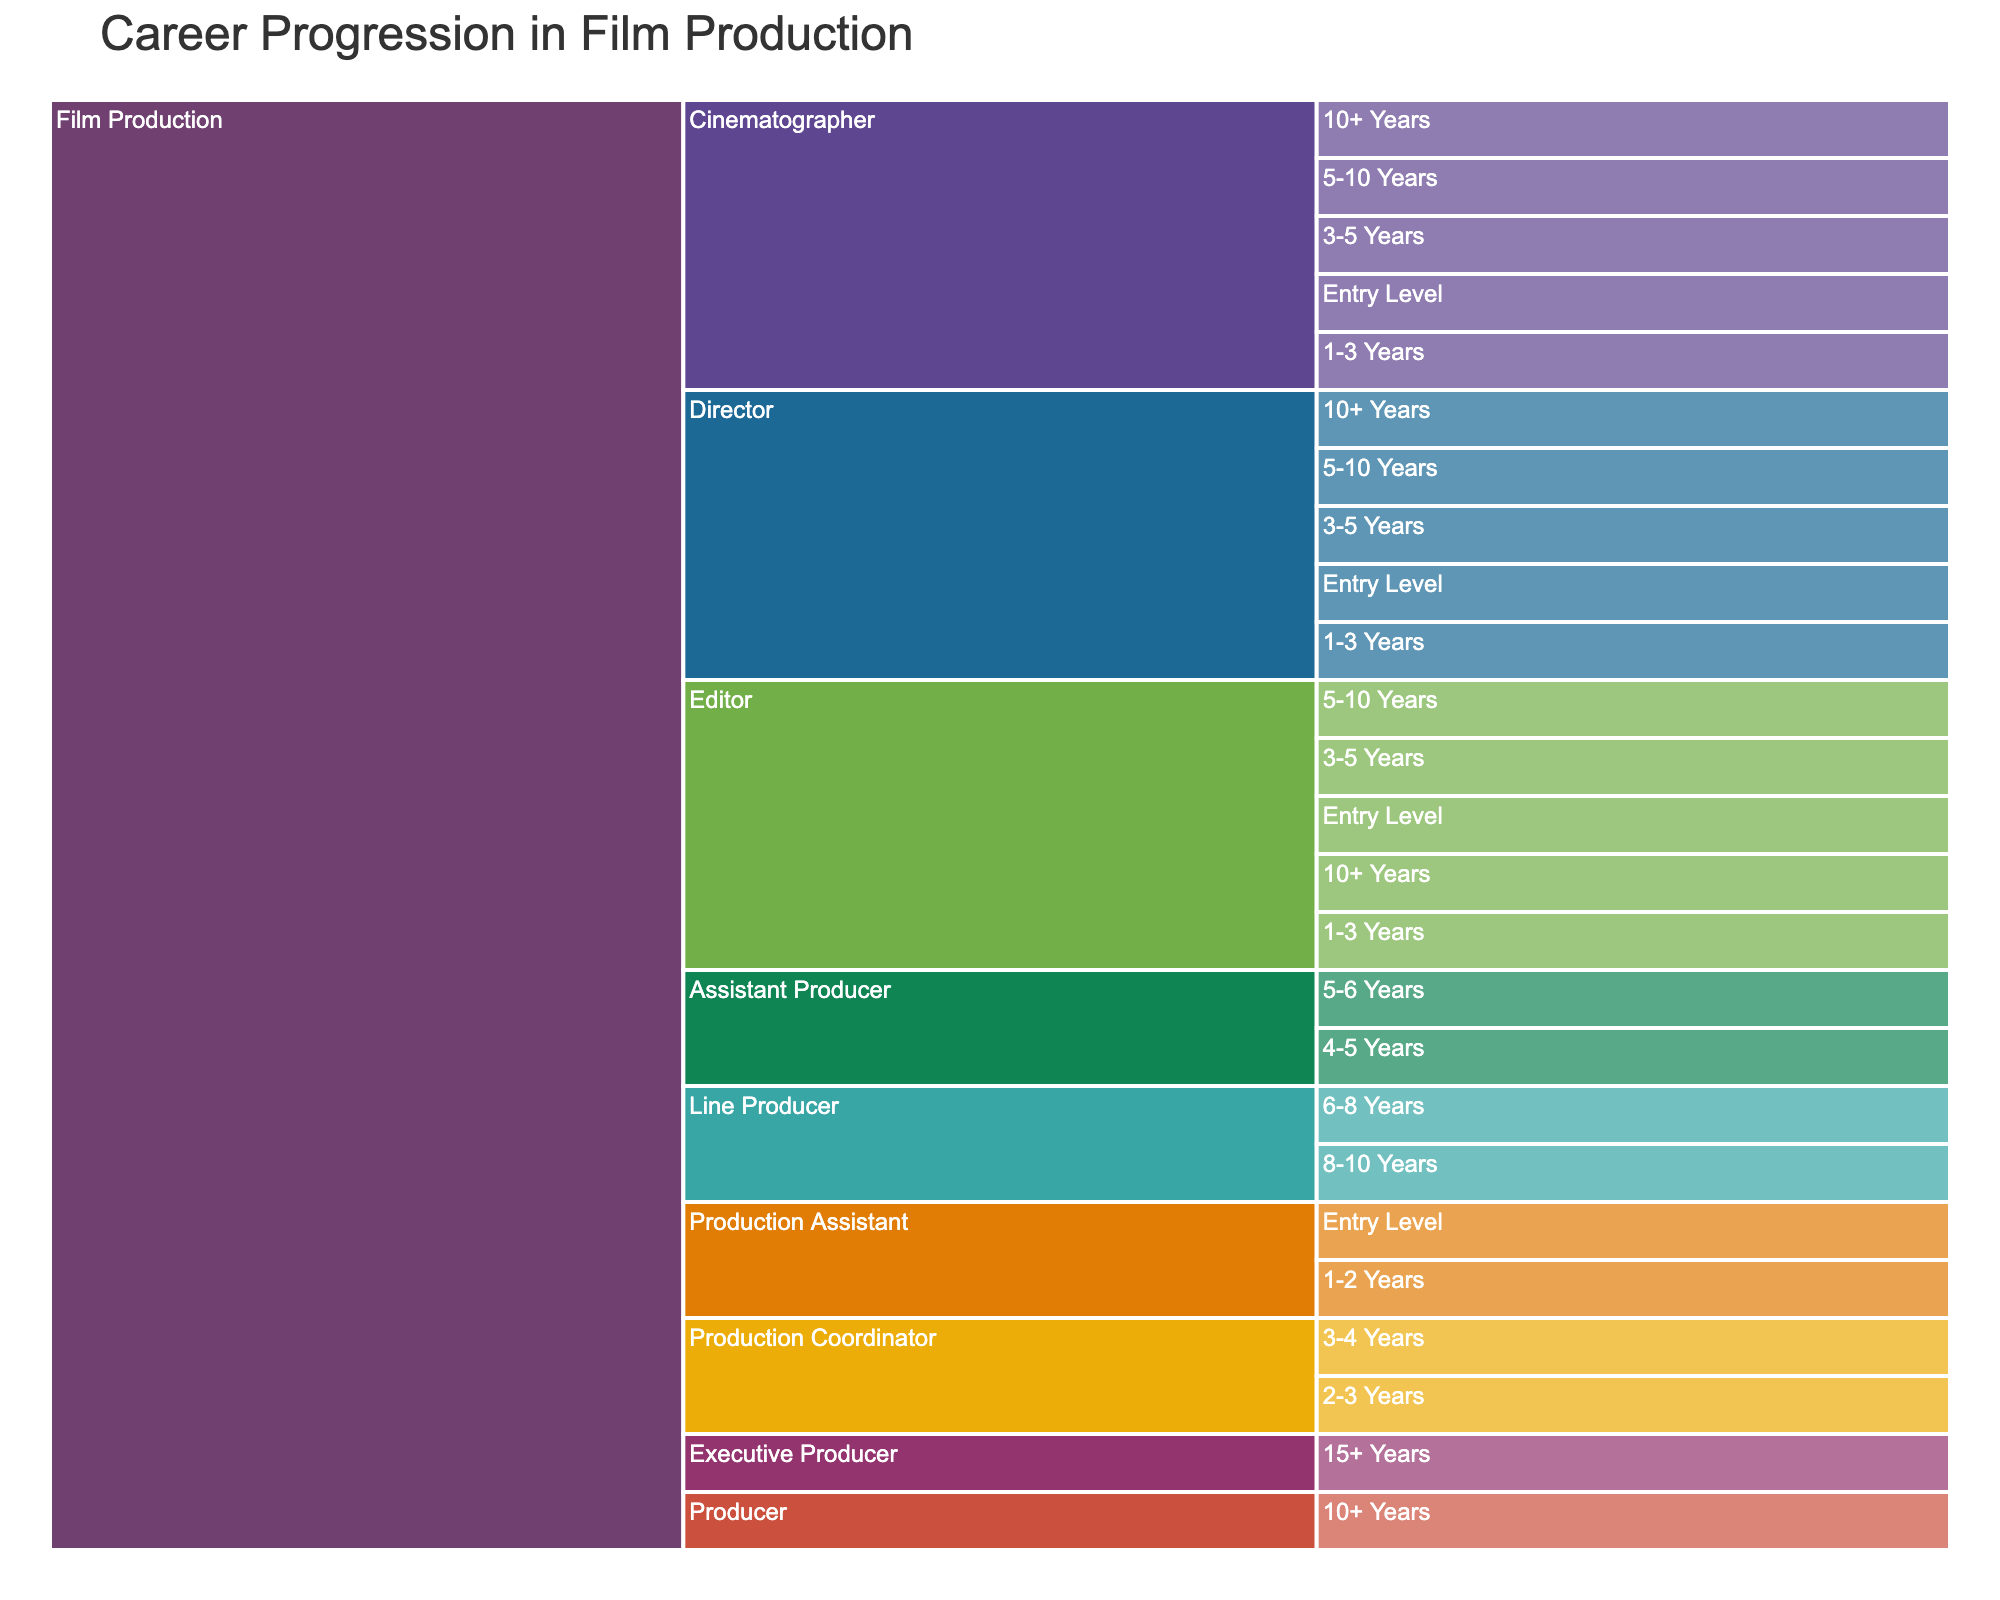What is the title of the Icicle chart? The title can be found at the top of the figure; it is usually large and prominently placed. In this case, the title indicates the subject of the chart.
Answer: Career Progression in Film Production What are the three main elements used in the path hierarchy in this Icicle chart? The chart uses three main hierarchical elements to structure the data: Career, Role, and Experience Level. These elements define the progression path in the chart.
Answer: Career, Role, Experience Level Which roles are shown in the figure as starting points for entry-level positions? To find entry-level positions, we look at the branches of the Icicle chart that are marked as "Entry Level". The roles associated with these branches are the entry-level positions.
Answer: Production Assistant, Director, Cinematographer, Editor How many experience levels are associated with the role 'Line Producer'? The role 'Line Producer' branches out into subcategories based on experience levels. Counting these subcategories will give the answer.
Answer: 2 What is the highest specified experience level in the chart, and which roles are associated with it? To find the highest experience level, look at the deepest nodes in the chart. In this figure, the highest experience level and its associated roles will be listed there.
Answer: 15+ Years, Executive Producer Which role has the longest progression path by experience level, and how many levels are there? The length of the progression path can be determined by counting the number of experience levels for each role. The role with the most levels has the longest path.
Answer: Director, 5 levels How does the path for 'Assistant Producer' differ from that of 'Cinematographer' in terms of experience levels? Comparing the experience levels for each role involves looking at both paths and counting the experience level nodes for each role. 'Assistant Producer' has fewer nodes compared to 'Cinematographer'.
Answer: Assistant Producer: 2 levels, Cinematographer: 5 levels Which role has its first experience level marked as 4-5 years? By examining each branch and their corresponding experience levels, we can identify which role's first experience level is marked as 4-5 years.
Answer: Assistant Producer Are there any roles with experience levels extending beyond 10 years? To answer this, look through the nodes in the chart to find any roles that have branches extending to experience levels that are 10+ years.
Answer: Yes, Producer, Executive Producer, Director, Cinematographer, Editor Which roles intersect with 'Production Coordinator', and how do their experience levels compare? To find intersecting roles, look at the branches stemming from 'Production Coordinator' and identify adjacent roles. Then, compare their experience levels to see how they overlap or deviate.
Answer: Assistant Producer intersects with 'Production Coordinator' at a higher experience level 